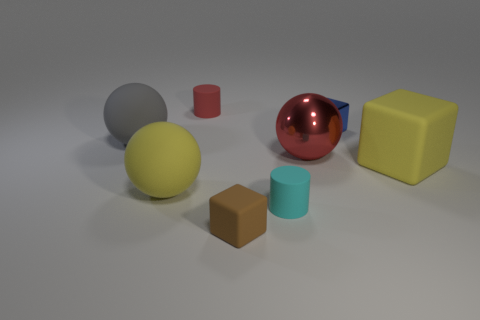Are there any other things that are the same size as the yellow rubber ball?
Your answer should be compact. Yes. Do the tiny blue thing and the large yellow sphere have the same material?
Offer a very short reply. No. What is the shape of the rubber object that is both behind the small cyan cylinder and in front of the yellow block?
Your response must be concise. Sphere. There is a cylinder to the left of the small rubber cylinder that is right of the red cylinder; what size is it?
Your answer should be very brief. Small. How many small cyan matte things are the same shape as the tiny metallic thing?
Provide a short and direct response. 0. Does the small metallic block have the same color as the large metal sphere?
Your answer should be very brief. No. Is there any other thing that has the same shape as the large red metallic object?
Keep it short and to the point. Yes. Are there any rubber cylinders that have the same color as the big shiny sphere?
Offer a very short reply. Yes. Are the large thing that is in front of the yellow matte block and the small red thing that is behind the small matte block made of the same material?
Offer a very short reply. Yes. What is the color of the big rubber block?
Make the answer very short. Yellow. 